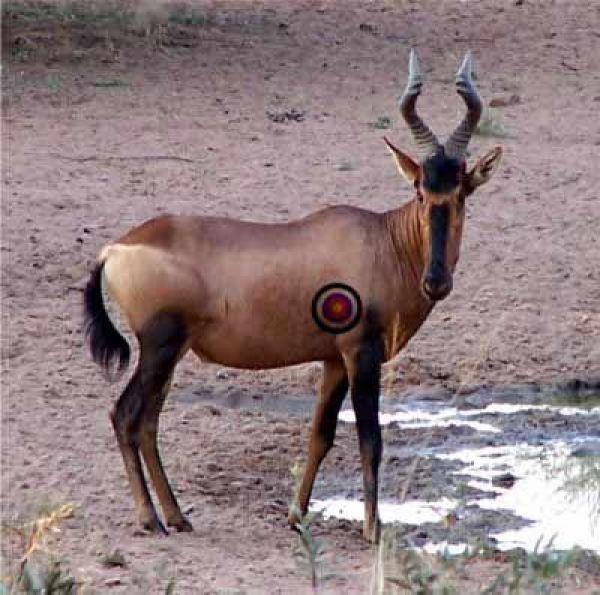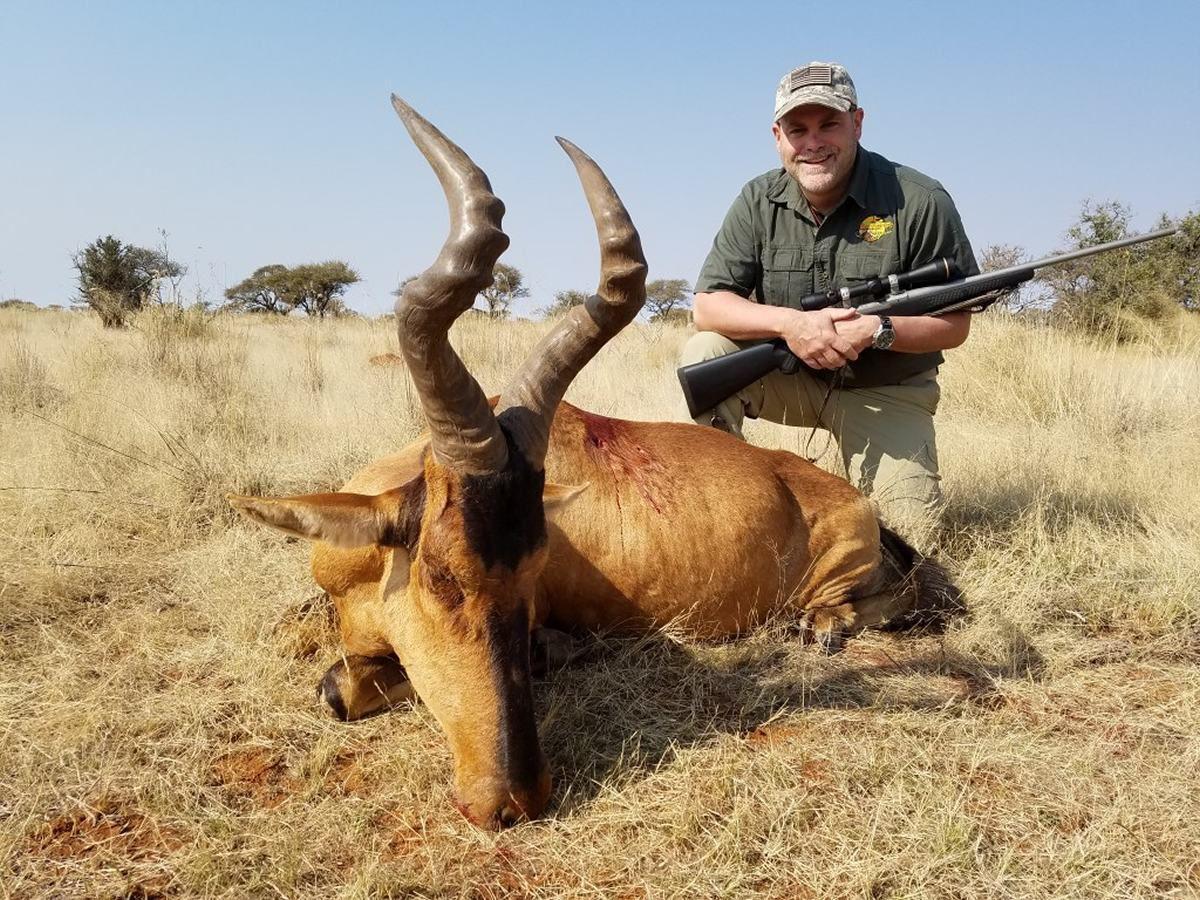The first image is the image on the left, the second image is the image on the right. Considering the images on both sides, is "In one of the images there is a hunter posing behind an animal." valid? Answer yes or no. Yes. 